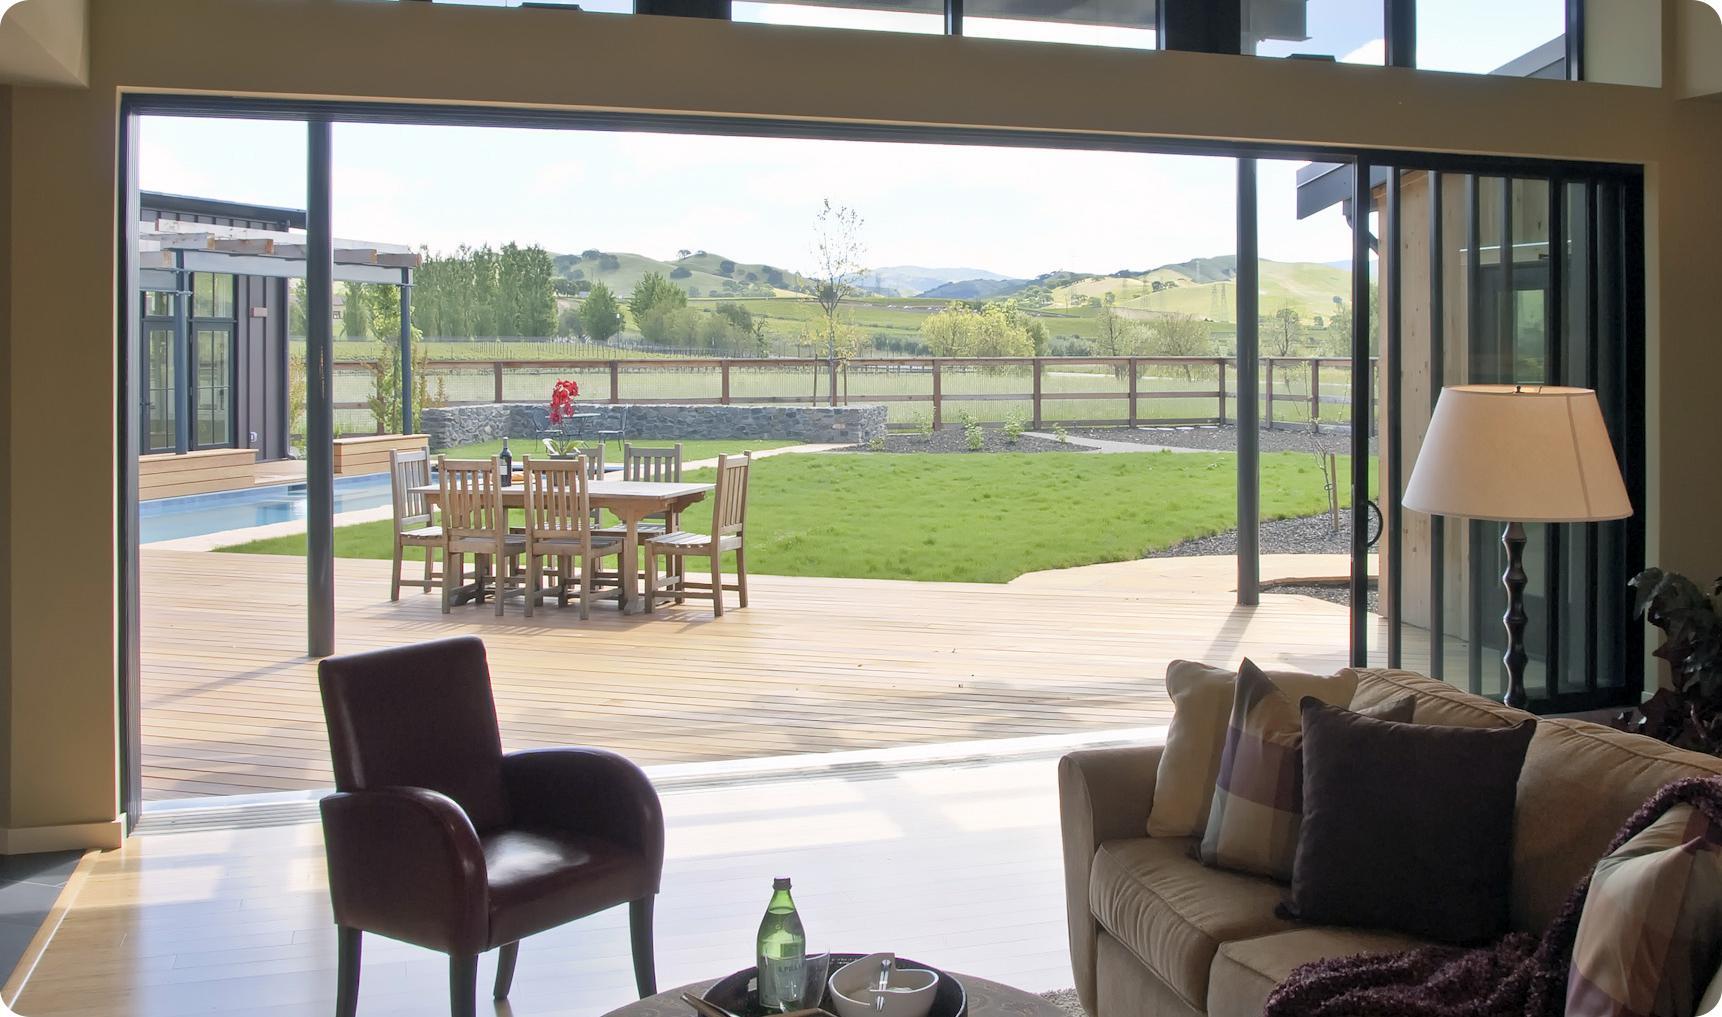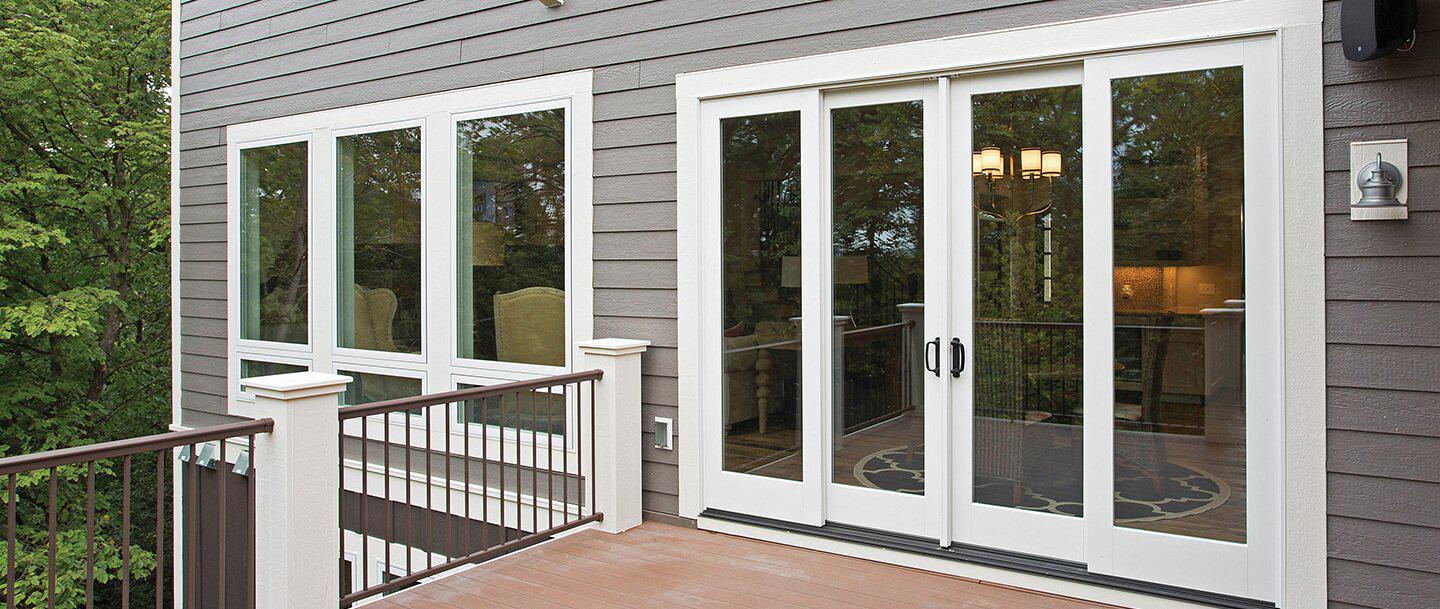The first image is the image on the left, the second image is the image on the right. Considering the images on both sides, is "In at least image there are six chairs surrounding a square table on the patio." valid? Answer yes or no. Yes. The first image is the image on the left, the second image is the image on the right. For the images displayed, is the sentence "The right image is an exterior view of a wall of sliding glass doors, with stone-type surface in front, that face the camera and reveal a spacious furnished interior." factually correct? Answer yes or no. No. 